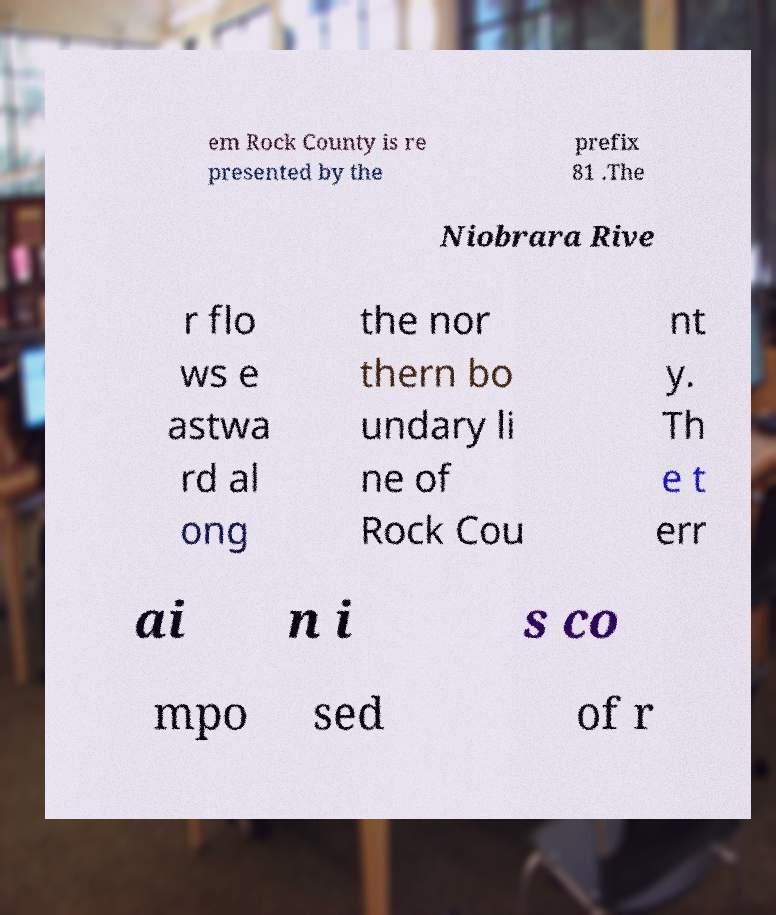There's text embedded in this image that I need extracted. Can you transcribe it verbatim? em Rock County is re presented by the prefix 81 .The Niobrara Rive r flo ws e astwa rd al ong the nor thern bo undary li ne of Rock Cou nt y. Th e t err ai n i s co mpo sed of r 